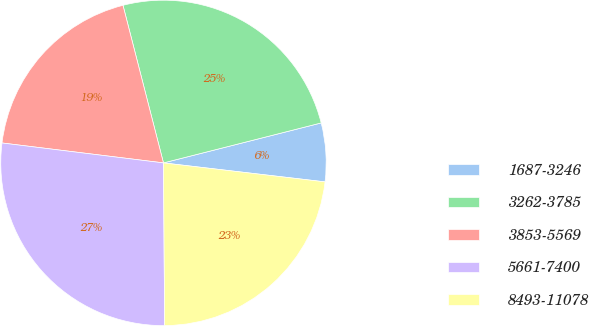<chart> <loc_0><loc_0><loc_500><loc_500><pie_chart><fcel>1687-3246<fcel>3262-3785<fcel>3853-5569<fcel>5661-7400<fcel>8493-11078<nl><fcel>5.81%<fcel>25.05%<fcel>19.04%<fcel>27.07%<fcel>23.02%<nl></chart> 